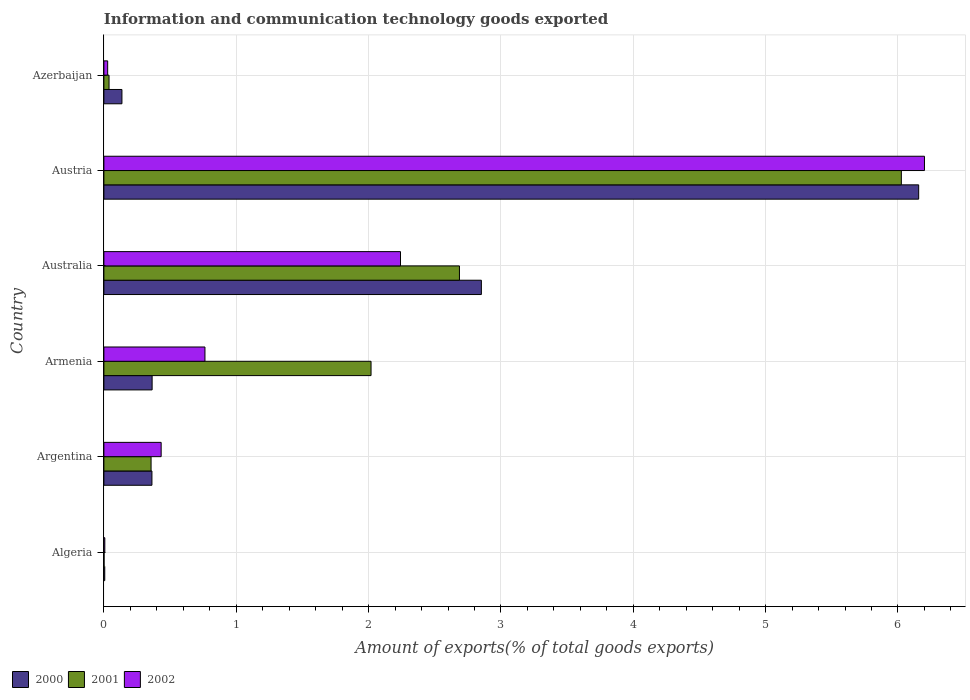Are the number of bars per tick equal to the number of legend labels?
Make the answer very short. Yes. Are the number of bars on each tick of the Y-axis equal?
Give a very brief answer. Yes. What is the label of the 3rd group of bars from the top?
Offer a terse response. Australia. What is the amount of goods exported in 2001 in Algeria?
Offer a terse response. 0. Across all countries, what is the maximum amount of goods exported in 2002?
Provide a short and direct response. 6.2. Across all countries, what is the minimum amount of goods exported in 2002?
Offer a terse response. 0.01. In which country was the amount of goods exported in 2002 maximum?
Your answer should be compact. Austria. In which country was the amount of goods exported in 2002 minimum?
Keep it short and to the point. Algeria. What is the total amount of goods exported in 2001 in the graph?
Give a very brief answer. 11.13. What is the difference between the amount of goods exported in 2001 in Algeria and that in Azerbaijan?
Ensure brevity in your answer.  -0.04. What is the difference between the amount of goods exported in 2000 in Argentina and the amount of goods exported in 2002 in Algeria?
Give a very brief answer. 0.36. What is the average amount of goods exported in 2000 per country?
Keep it short and to the point. 1.65. What is the difference between the amount of goods exported in 2000 and amount of goods exported in 2002 in Azerbaijan?
Ensure brevity in your answer.  0.11. In how many countries, is the amount of goods exported in 2000 greater than 2.4 %?
Keep it short and to the point. 2. What is the ratio of the amount of goods exported in 2002 in Austria to that in Azerbaijan?
Ensure brevity in your answer.  217.4. What is the difference between the highest and the second highest amount of goods exported in 2002?
Offer a very short reply. 3.96. What is the difference between the highest and the lowest amount of goods exported in 2000?
Keep it short and to the point. 6.15. Is the sum of the amount of goods exported in 2000 in Argentina and Australia greater than the maximum amount of goods exported in 2001 across all countries?
Give a very brief answer. No. Is it the case that in every country, the sum of the amount of goods exported in 2000 and amount of goods exported in 2001 is greater than the amount of goods exported in 2002?
Your response must be concise. Yes. How many bars are there?
Offer a very short reply. 18. Are all the bars in the graph horizontal?
Ensure brevity in your answer.  Yes. Are the values on the major ticks of X-axis written in scientific E-notation?
Provide a succinct answer. No. Where does the legend appear in the graph?
Offer a very short reply. Bottom left. What is the title of the graph?
Your answer should be compact. Information and communication technology goods exported. What is the label or title of the X-axis?
Offer a very short reply. Amount of exports(% of total goods exports). What is the Amount of exports(% of total goods exports) of 2000 in Algeria?
Your answer should be compact. 0.01. What is the Amount of exports(% of total goods exports) of 2001 in Algeria?
Give a very brief answer. 0. What is the Amount of exports(% of total goods exports) in 2002 in Algeria?
Offer a terse response. 0.01. What is the Amount of exports(% of total goods exports) in 2000 in Argentina?
Provide a short and direct response. 0.36. What is the Amount of exports(% of total goods exports) of 2001 in Argentina?
Offer a terse response. 0.36. What is the Amount of exports(% of total goods exports) in 2002 in Argentina?
Offer a terse response. 0.43. What is the Amount of exports(% of total goods exports) in 2000 in Armenia?
Provide a short and direct response. 0.36. What is the Amount of exports(% of total goods exports) in 2001 in Armenia?
Your answer should be very brief. 2.02. What is the Amount of exports(% of total goods exports) in 2002 in Armenia?
Provide a succinct answer. 0.76. What is the Amount of exports(% of total goods exports) in 2000 in Australia?
Give a very brief answer. 2.85. What is the Amount of exports(% of total goods exports) of 2001 in Australia?
Offer a very short reply. 2.69. What is the Amount of exports(% of total goods exports) of 2002 in Australia?
Give a very brief answer. 2.24. What is the Amount of exports(% of total goods exports) in 2000 in Austria?
Your response must be concise. 6.16. What is the Amount of exports(% of total goods exports) in 2001 in Austria?
Ensure brevity in your answer.  6.03. What is the Amount of exports(% of total goods exports) of 2002 in Austria?
Provide a succinct answer. 6.2. What is the Amount of exports(% of total goods exports) in 2000 in Azerbaijan?
Make the answer very short. 0.14. What is the Amount of exports(% of total goods exports) in 2001 in Azerbaijan?
Give a very brief answer. 0.04. What is the Amount of exports(% of total goods exports) in 2002 in Azerbaijan?
Your answer should be very brief. 0.03. Across all countries, what is the maximum Amount of exports(% of total goods exports) of 2000?
Make the answer very short. 6.16. Across all countries, what is the maximum Amount of exports(% of total goods exports) of 2001?
Your response must be concise. 6.03. Across all countries, what is the maximum Amount of exports(% of total goods exports) of 2002?
Provide a succinct answer. 6.2. Across all countries, what is the minimum Amount of exports(% of total goods exports) in 2000?
Provide a short and direct response. 0.01. Across all countries, what is the minimum Amount of exports(% of total goods exports) in 2001?
Provide a succinct answer. 0. Across all countries, what is the minimum Amount of exports(% of total goods exports) in 2002?
Offer a terse response. 0.01. What is the total Amount of exports(% of total goods exports) in 2000 in the graph?
Your answer should be compact. 9.88. What is the total Amount of exports(% of total goods exports) of 2001 in the graph?
Your answer should be compact. 11.13. What is the total Amount of exports(% of total goods exports) of 2002 in the graph?
Provide a succinct answer. 9.67. What is the difference between the Amount of exports(% of total goods exports) in 2000 in Algeria and that in Argentina?
Your response must be concise. -0.36. What is the difference between the Amount of exports(% of total goods exports) in 2001 in Algeria and that in Argentina?
Your response must be concise. -0.36. What is the difference between the Amount of exports(% of total goods exports) of 2002 in Algeria and that in Argentina?
Provide a succinct answer. -0.43. What is the difference between the Amount of exports(% of total goods exports) of 2000 in Algeria and that in Armenia?
Offer a terse response. -0.36. What is the difference between the Amount of exports(% of total goods exports) of 2001 in Algeria and that in Armenia?
Provide a succinct answer. -2.02. What is the difference between the Amount of exports(% of total goods exports) in 2002 in Algeria and that in Armenia?
Give a very brief answer. -0.76. What is the difference between the Amount of exports(% of total goods exports) of 2000 in Algeria and that in Australia?
Your answer should be compact. -2.85. What is the difference between the Amount of exports(% of total goods exports) in 2001 in Algeria and that in Australia?
Your answer should be compact. -2.69. What is the difference between the Amount of exports(% of total goods exports) of 2002 in Algeria and that in Australia?
Provide a short and direct response. -2.23. What is the difference between the Amount of exports(% of total goods exports) in 2000 in Algeria and that in Austria?
Provide a succinct answer. -6.15. What is the difference between the Amount of exports(% of total goods exports) of 2001 in Algeria and that in Austria?
Keep it short and to the point. -6.02. What is the difference between the Amount of exports(% of total goods exports) of 2002 in Algeria and that in Austria?
Give a very brief answer. -6.19. What is the difference between the Amount of exports(% of total goods exports) of 2000 in Algeria and that in Azerbaijan?
Give a very brief answer. -0.13. What is the difference between the Amount of exports(% of total goods exports) of 2001 in Algeria and that in Azerbaijan?
Offer a very short reply. -0.04. What is the difference between the Amount of exports(% of total goods exports) in 2002 in Algeria and that in Azerbaijan?
Your answer should be compact. -0.02. What is the difference between the Amount of exports(% of total goods exports) in 2000 in Argentina and that in Armenia?
Your response must be concise. -0. What is the difference between the Amount of exports(% of total goods exports) of 2001 in Argentina and that in Armenia?
Your answer should be very brief. -1.66. What is the difference between the Amount of exports(% of total goods exports) of 2002 in Argentina and that in Armenia?
Offer a very short reply. -0.33. What is the difference between the Amount of exports(% of total goods exports) in 2000 in Argentina and that in Australia?
Offer a very short reply. -2.49. What is the difference between the Amount of exports(% of total goods exports) of 2001 in Argentina and that in Australia?
Your answer should be compact. -2.33. What is the difference between the Amount of exports(% of total goods exports) in 2002 in Argentina and that in Australia?
Your answer should be compact. -1.81. What is the difference between the Amount of exports(% of total goods exports) in 2000 in Argentina and that in Austria?
Keep it short and to the point. -5.79. What is the difference between the Amount of exports(% of total goods exports) of 2001 in Argentina and that in Austria?
Provide a short and direct response. -5.67. What is the difference between the Amount of exports(% of total goods exports) of 2002 in Argentina and that in Austria?
Your answer should be compact. -5.77. What is the difference between the Amount of exports(% of total goods exports) of 2000 in Argentina and that in Azerbaijan?
Make the answer very short. 0.23. What is the difference between the Amount of exports(% of total goods exports) in 2001 in Argentina and that in Azerbaijan?
Make the answer very short. 0.32. What is the difference between the Amount of exports(% of total goods exports) of 2002 in Argentina and that in Azerbaijan?
Make the answer very short. 0.4. What is the difference between the Amount of exports(% of total goods exports) of 2000 in Armenia and that in Australia?
Your answer should be very brief. -2.49. What is the difference between the Amount of exports(% of total goods exports) in 2001 in Armenia and that in Australia?
Ensure brevity in your answer.  -0.67. What is the difference between the Amount of exports(% of total goods exports) of 2002 in Armenia and that in Australia?
Your response must be concise. -1.48. What is the difference between the Amount of exports(% of total goods exports) of 2000 in Armenia and that in Austria?
Provide a short and direct response. -5.79. What is the difference between the Amount of exports(% of total goods exports) of 2001 in Armenia and that in Austria?
Ensure brevity in your answer.  -4.01. What is the difference between the Amount of exports(% of total goods exports) of 2002 in Armenia and that in Austria?
Ensure brevity in your answer.  -5.44. What is the difference between the Amount of exports(% of total goods exports) in 2000 in Armenia and that in Azerbaijan?
Ensure brevity in your answer.  0.23. What is the difference between the Amount of exports(% of total goods exports) of 2001 in Armenia and that in Azerbaijan?
Make the answer very short. 1.98. What is the difference between the Amount of exports(% of total goods exports) in 2002 in Armenia and that in Azerbaijan?
Keep it short and to the point. 0.74. What is the difference between the Amount of exports(% of total goods exports) in 2000 in Australia and that in Austria?
Keep it short and to the point. -3.3. What is the difference between the Amount of exports(% of total goods exports) of 2001 in Australia and that in Austria?
Your response must be concise. -3.34. What is the difference between the Amount of exports(% of total goods exports) of 2002 in Australia and that in Austria?
Provide a succinct answer. -3.96. What is the difference between the Amount of exports(% of total goods exports) of 2000 in Australia and that in Azerbaijan?
Provide a short and direct response. 2.72. What is the difference between the Amount of exports(% of total goods exports) of 2001 in Australia and that in Azerbaijan?
Provide a succinct answer. 2.65. What is the difference between the Amount of exports(% of total goods exports) in 2002 in Australia and that in Azerbaijan?
Offer a terse response. 2.21. What is the difference between the Amount of exports(% of total goods exports) of 2000 in Austria and that in Azerbaijan?
Offer a very short reply. 6.02. What is the difference between the Amount of exports(% of total goods exports) of 2001 in Austria and that in Azerbaijan?
Your answer should be very brief. 5.99. What is the difference between the Amount of exports(% of total goods exports) in 2002 in Austria and that in Azerbaijan?
Your answer should be very brief. 6.17. What is the difference between the Amount of exports(% of total goods exports) of 2000 in Algeria and the Amount of exports(% of total goods exports) of 2001 in Argentina?
Give a very brief answer. -0.35. What is the difference between the Amount of exports(% of total goods exports) of 2000 in Algeria and the Amount of exports(% of total goods exports) of 2002 in Argentina?
Make the answer very short. -0.43. What is the difference between the Amount of exports(% of total goods exports) in 2001 in Algeria and the Amount of exports(% of total goods exports) in 2002 in Argentina?
Keep it short and to the point. -0.43. What is the difference between the Amount of exports(% of total goods exports) of 2000 in Algeria and the Amount of exports(% of total goods exports) of 2001 in Armenia?
Your response must be concise. -2.01. What is the difference between the Amount of exports(% of total goods exports) of 2000 in Algeria and the Amount of exports(% of total goods exports) of 2002 in Armenia?
Ensure brevity in your answer.  -0.76. What is the difference between the Amount of exports(% of total goods exports) of 2001 in Algeria and the Amount of exports(% of total goods exports) of 2002 in Armenia?
Your answer should be compact. -0.76. What is the difference between the Amount of exports(% of total goods exports) of 2000 in Algeria and the Amount of exports(% of total goods exports) of 2001 in Australia?
Your answer should be compact. -2.68. What is the difference between the Amount of exports(% of total goods exports) of 2000 in Algeria and the Amount of exports(% of total goods exports) of 2002 in Australia?
Your answer should be very brief. -2.23. What is the difference between the Amount of exports(% of total goods exports) of 2001 in Algeria and the Amount of exports(% of total goods exports) of 2002 in Australia?
Keep it short and to the point. -2.24. What is the difference between the Amount of exports(% of total goods exports) in 2000 in Algeria and the Amount of exports(% of total goods exports) in 2001 in Austria?
Keep it short and to the point. -6.02. What is the difference between the Amount of exports(% of total goods exports) of 2000 in Algeria and the Amount of exports(% of total goods exports) of 2002 in Austria?
Ensure brevity in your answer.  -6.19. What is the difference between the Amount of exports(% of total goods exports) of 2001 in Algeria and the Amount of exports(% of total goods exports) of 2002 in Austria?
Your answer should be compact. -6.2. What is the difference between the Amount of exports(% of total goods exports) of 2000 in Algeria and the Amount of exports(% of total goods exports) of 2001 in Azerbaijan?
Provide a short and direct response. -0.03. What is the difference between the Amount of exports(% of total goods exports) of 2000 in Algeria and the Amount of exports(% of total goods exports) of 2002 in Azerbaijan?
Provide a succinct answer. -0.02. What is the difference between the Amount of exports(% of total goods exports) of 2001 in Algeria and the Amount of exports(% of total goods exports) of 2002 in Azerbaijan?
Your response must be concise. -0.03. What is the difference between the Amount of exports(% of total goods exports) of 2000 in Argentina and the Amount of exports(% of total goods exports) of 2001 in Armenia?
Provide a short and direct response. -1.66. What is the difference between the Amount of exports(% of total goods exports) in 2000 in Argentina and the Amount of exports(% of total goods exports) in 2002 in Armenia?
Your answer should be compact. -0.4. What is the difference between the Amount of exports(% of total goods exports) of 2001 in Argentina and the Amount of exports(% of total goods exports) of 2002 in Armenia?
Your answer should be very brief. -0.41. What is the difference between the Amount of exports(% of total goods exports) of 2000 in Argentina and the Amount of exports(% of total goods exports) of 2001 in Australia?
Provide a short and direct response. -2.32. What is the difference between the Amount of exports(% of total goods exports) of 2000 in Argentina and the Amount of exports(% of total goods exports) of 2002 in Australia?
Offer a terse response. -1.88. What is the difference between the Amount of exports(% of total goods exports) of 2001 in Argentina and the Amount of exports(% of total goods exports) of 2002 in Australia?
Make the answer very short. -1.88. What is the difference between the Amount of exports(% of total goods exports) of 2000 in Argentina and the Amount of exports(% of total goods exports) of 2001 in Austria?
Provide a short and direct response. -5.66. What is the difference between the Amount of exports(% of total goods exports) in 2000 in Argentina and the Amount of exports(% of total goods exports) in 2002 in Austria?
Your answer should be very brief. -5.84. What is the difference between the Amount of exports(% of total goods exports) of 2001 in Argentina and the Amount of exports(% of total goods exports) of 2002 in Austria?
Your answer should be compact. -5.84. What is the difference between the Amount of exports(% of total goods exports) of 2000 in Argentina and the Amount of exports(% of total goods exports) of 2001 in Azerbaijan?
Your answer should be very brief. 0.32. What is the difference between the Amount of exports(% of total goods exports) in 2000 in Argentina and the Amount of exports(% of total goods exports) in 2002 in Azerbaijan?
Make the answer very short. 0.33. What is the difference between the Amount of exports(% of total goods exports) of 2001 in Argentina and the Amount of exports(% of total goods exports) of 2002 in Azerbaijan?
Your answer should be compact. 0.33. What is the difference between the Amount of exports(% of total goods exports) of 2000 in Armenia and the Amount of exports(% of total goods exports) of 2001 in Australia?
Your response must be concise. -2.32. What is the difference between the Amount of exports(% of total goods exports) of 2000 in Armenia and the Amount of exports(% of total goods exports) of 2002 in Australia?
Give a very brief answer. -1.88. What is the difference between the Amount of exports(% of total goods exports) in 2001 in Armenia and the Amount of exports(% of total goods exports) in 2002 in Australia?
Your answer should be very brief. -0.22. What is the difference between the Amount of exports(% of total goods exports) of 2000 in Armenia and the Amount of exports(% of total goods exports) of 2001 in Austria?
Your answer should be very brief. -5.66. What is the difference between the Amount of exports(% of total goods exports) of 2000 in Armenia and the Amount of exports(% of total goods exports) of 2002 in Austria?
Your response must be concise. -5.84. What is the difference between the Amount of exports(% of total goods exports) in 2001 in Armenia and the Amount of exports(% of total goods exports) in 2002 in Austria?
Keep it short and to the point. -4.18. What is the difference between the Amount of exports(% of total goods exports) of 2000 in Armenia and the Amount of exports(% of total goods exports) of 2001 in Azerbaijan?
Make the answer very short. 0.33. What is the difference between the Amount of exports(% of total goods exports) in 2000 in Armenia and the Amount of exports(% of total goods exports) in 2002 in Azerbaijan?
Your answer should be very brief. 0.34. What is the difference between the Amount of exports(% of total goods exports) in 2001 in Armenia and the Amount of exports(% of total goods exports) in 2002 in Azerbaijan?
Your answer should be compact. 1.99. What is the difference between the Amount of exports(% of total goods exports) in 2000 in Australia and the Amount of exports(% of total goods exports) in 2001 in Austria?
Keep it short and to the point. -3.17. What is the difference between the Amount of exports(% of total goods exports) in 2000 in Australia and the Amount of exports(% of total goods exports) in 2002 in Austria?
Your answer should be very brief. -3.35. What is the difference between the Amount of exports(% of total goods exports) of 2001 in Australia and the Amount of exports(% of total goods exports) of 2002 in Austria?
Keep it short and to the point. -3.51. What is the difference between the Amount of exports(% of total goods exports) in 2000 in Australia and the Amount of exports(% of total goods exports) in 2001 in Azerbaijan?
Provide a short and direct response. 2.81. What is the difference between the Amount of exports(% of total goods exports) in 2000 in Australia and the Amount of exports(% of total goods exports) in 2002 in Azerbaijan?
Give a very brief answer. 2.82. What is the difference between the Amount of exports(% of total goods exports) in 2001 in Australia and the Amount of exports(% of total goods exports) in 2002 in Azerbaijan?
Keep it short and to the point. 2.66. What is the difference between the Amount of exports(% of total goods exports) of 2000 in Austria and the Amount of exports(% of total goods exports) of 2001 in Azerbaijan?
Your response must be concise. 6.12. What is the difference between the Amount of exports(% of total goods exports) of 2000 in Austria and the Amount of exports(% of total goods exports) of 2002 in Azerbaijan?
Ensure brevity in your answer.  6.13. What is the difference between the Amount of exports(% of total goods exports) of 2001 in Austria and the Amount of exports(% of total goods exports) of 2002 in Azerbaijan?
Make the answer very short. 6. What is the average Amount of exports(% of total goods exports) of 2000 per country?
Keep it short and to the point. 1.65. What is the average Amount of exports(% of total goods exports) in 2001 per country?
Offer a terse response. 1.85. What is the average Amount of exports(% of total goods exports) in 2002 per country?
Keep it short and to the point. 1.61. What is the difference between the Amount of exports(% of total goods exports) in 2000 and Amount of exports(% of total goods exports) in 2001 in Algeria?
Your response must be concise. 0.01. What is the difference between the Amount of exports(% of total goods exports) of 2000 and Amount of exports(% of total goods exports) of 2002 in Algeria?
Give a very brief answer. -0. What is the difference between the Amount of exports(% of total goods exports) of 2001 and Amount of exports(% of total goods exports) of 2002 in Algeria?
Offer a very short reply. -0.01. What is the difference between the Amount of exports(% of total goods exports) in 2000 and Amount of exports(% of total goods exports) in 2001 in Argentina?
Offer a very short reply. 0.01. What is the difference between the Amount of exports(% of total goods exports) in 2000 and Amount of exports(% of total goods exports) in 2002 in Argentina?
Your answer should be very brief. -0.07. What is the difference between the Amount of exports(% of total goods exports) in 2001 and Amount of exports(% of total goods exports) in 2002 in Argentina?
Provide a succinct answer. -0.08. What is the difference between the Amount of exports(% of total goods exports) of 2000 and Amount of exports(% of total goods exports) of 2001 in Armenia?
Your response must be concise. -1.65. What is the difference between the Amount of exports(% of total goods exports) of 2000 and Amount of exports(% of total goods exports) of 2002 in Armenia?
Your response must be concise. -0.4. What is the difference between the Amount of exports(% of total goods exports) of 2001 and Amount of exports(% of total goods exports) of 2002 in Armenia?
Keep it short and to the point. 1.25. What is the difference between the Amount of exports(% of total goods exports) in 2000 and Amount of exports(% of total goods exports) in 2001 in Australia?
Make the answer very short. 0.17. What is the difference between the Amount of exports(% of total goods exports) in 2000 and Amount of exports(% of total goods exports) in 2002 in Australia?
Your answer should be very brief. 0.61. What is the difference between the Amount of exports(% of total goods exports) of 2001 and Amount of exports(% of total goods exports) of 2002 in Australia?
Make the answer very short. 0.45. What is the difference between the Amount of exports(% of total goods exports) in 2000 and Amount of exports(% of total goods exports) in 2001 in Austria?
Provide a short and direct response. 0.13. What is the difference between the Amount of exports(% of total goods exports) in 2000 and Amount of exports(% of total goods exports) in 2002 in Austria?
Make the answer very short. -0.04. What is the difference between the Amount of exports(% of total goods exports) in 2001 and Amount of exports(% of total goods exports) in 2002 in Austria?
Offer a very short reply. -0.17. What is the difference between the Amount of exports(% of total goods exports) in 2000 and Amount of exports(% of total goods exports) in 2001 in Azerbaijan?
Give a very brief answer. 0.1. What is the difference between the Amount of exports(% of total goods exports) of 2000 and Amount of exports(% of total goods exports) of 2002 in Azerbaijan?
Give a very brief answer. 0.11. What is the difference between the Amount of exports(% of total goods exports) in 2001 and Amount of exports(% of total goods exports) in 2002 in Azerbaijan?
Make the answer very short. 0.01. What is the ratio of the Amount of exports(% of total goods exports) of 2000 in Algeria to that in Argentina?
Give a very brief answer. 0.02. What is the ratio of the Amount of exports(% of total goods exports) of 2001 in Algeria to that in Argentina?
Ensure brevity in your answer.  0. What is the ratio of the Amount of exports(% of total goods exports) of 2002 in Algeria to that in Argentina?
Provide a short and direct response. 0.02. What is the ratio of the Amount of exports(% of total goods exports) of 2000 in Algeria to that in Armenia?
Ensure brevity in your answer.  0.02. What is the ratio of the Amount of exports(% of total goods exports) of 2001 in Algeria to that in Armenia?
Provide a succinct answer. 0. What is the ratio of the Amount of exports(% of total goods exports) in 2002 in Algeria to that in Armenia?
Provide a succinct answer. 0.01. What is the ratio of the Amount of exports(% of total goods exports) in 2000 in Algeria to that in Australia?
Your response must be concise. 0. What is the ratio of the Amount of exports(% of total goods exports) in 2001 in Algeria to that in Australia?
Offer a very short reply. 0. What is the ratio of the Amount of exports(% of total goods exports) of 2002 in Algeria to that in Australia?
Ensure brevity in your answer.  0. What is the ratio of the Amount of exports(% of total goods exports) of 2000 in Algeria to that in Austria?
Offer a terse response. 0. What is the ratio of the Amount of exports(% of total goods exports) of 2001 in Algeria to that in Austria?
Provide a succinct answer. 0. What is the ratio of the Amount of exports(% of total goods exports) of 2002 in Algeria to that in Austria?
Offer a terse response. 0. What is the ratio of the Amount of exports(% of total goods exports) of 2000 in Algeria to that in Azerbaijan?
Ensure brevity in your answer.  0.05. What is the ratio of the Amount of exports(% of total goods exports) in 2001 in Algeria to that in Azerbaijan?
Your response must be concise. 0.03. What is the ratio of the Amount of exports(% of total goods exports) of 2002 in Algeria to that in Azerbaijan?
Your answer should be compact. 0.24. What is the ratio of the Amount of exports(% of total goods exports) in 2000 in Argentina to that in Armenia?
Offer a very short reply. 1. What is the ratio of the Amount of exports(% of total goods exports) in 2001 in Argentina to that in Armenia?
Your response must be concise. 0.18. What is the ratio of the Amount of exports(% of total goods exports) of 2002 in Argentina to that in Armenia?
Your response must be concise. 0.57. What is the ratio of the Amount of exports(% of total goods exports) in 2000 in Argentina to that in Australia?
Your answer should be very brief. 0.13. What is the ratio of the Amount of exports(% of total goods exports) of 2001 in Argentina to that in Australia?
Offer a terse response. 0.13. What is the ratio of the Amount of exports(% of total goods exports) of 2002 in Argentina to that in Australia?
Offer a terse response. 0.19. What is the ratio of the Amount of exports(% of total goods exports) in 2000 in Argentina to that in Austria?
Your response must be concise. 0.06. What is the ratio of the Amount of exports(% of total goods exports) in 2001 in Argentina to that in Austria?
Your response must be concise. 0.06. What is the ratio of the Amount of exports(% of total goods exports) of 2002 in Argentina to that in Austria?
Your answer should be very brief. 0.07. What is the ratio of the Amount of exports(% of total goods exports) in 2000 in Argentina to that in Azerbaijan?
Provide a short and direct response. 2.66. What is the ratio of the Amount of exports(% of total goods exports) in 2001 in Argentina to that in Azerbaijan?
Provide a succinct answer. 9.15. What is the ratio of the Amount of exports(% of total goods exports) in 2002 in Argentina to that in Azerbaijan?
Give a very brief answer. 15.17. What is the ratio of the Amount of exports(% of total goods exports) of 2000 in Armenia to that in Australia?
Your answer should be compact. 0.13. What is the ratio of the Amount of exports(% of total goods exports) in 2001 in Armenia to that in Australia?
Your response must be concise. 0.75. What is the ratio of the Amount of exports(% of total goods exports) in 2002 in Armenia to that in Australia?
Your response must be concise. 0.34. What is the ratio of the Amount of exports(% of total goods exports) of 2000 in Armenia to that in Austria?
Your response must be concise. 0.06. What is the ratio of the Amount of exports(% of total goods exports) in 2001 in Armenia to that in Austria?
Ensure brevity in your answer.  0.34. What is the ratio of the Amount of exports(% of total goods exports) in 2002 in Armenia to that in Austria?
Your response must be concise. 0.12. What is the ratio of the Amount of exports(% of total goods exports) in 2000 in Armenia to that in Azerbaijan?
Provide a succinct answer. 2.67. What is the ratio of the Amount of exports(% of total goods exports) in 2001 in Armenia to that in Azerbaijan?
Provide a short and direct response. 51.8. What is the ratio of the Amount of exports(% of total goods exports) of 2002 in Armenia to that in Azerbaijan?
Ensure brevity in your answer.  26.77. What is the ratio of the Amount of exports(% of total goods exports) of 2000 in Australia to that in Austria?
Your answer should be very brief. 0.46. What is the ratio of the Amount of exports(% of total goods exports) in 2001 in Australia to that in Austria?
Make the answer very short. 0.45. What is the ratio of the Amount of exports(% of total goods exports) of 2002 in Australia to that in Austria?
Make the answer very short. 0.36. What is the ratio of the Amount of exports(% of total goods exports) in 2000 in Australia to that in Azerbaijan?
Provide a succinct answer. 20.91. What is the ratio of the Amount of exports(% of total goods exports) in 2001 in Australia to that in Azerbaijan?
Make the answer very short. 68.95. What is the ratio of the Amount of exports(% of total goods exports) in 2002 in Australia to that in Azerbaijan?
Keep it short and to the point. 78.58. What is the ratio of the Amount of exports(% of total goods exports) in 2000 in Austria to that in Azerbaijan?
Your response must be concise. 45.14. What is the ratio of the Amount of exports(% of total goods exports) in 2001 in Austria to that in Azerbaijan?
Ensure brevity in your answer.  154.63. What is the ratio of the Amount of exports(% of total goods exports) in 2002 in Austria to that in Azerbaijan?
Offer a very short reply. 217.4. What is the difference between the highest and the second highest Amount of exports(% of total goods exports) of 2000?
Keep it short and to the point. 3.3. What is the difference between the highest and the second highest Amount of exports(% of total goods exports) of 2001?
Your response must be concise. 3.34. What is the difference between the highest and the second highest Amount of exports(% of total goods exports) of 2002?
Your response must be concise. 3.96. What is the difference between the highest and the lowest Amount of exports(% of total goods exports) of 2000?
Ensure brevity in your answer.  6.15. What is the difference between the highest and the lowest Amount of exports(% of total goods exports) in 2001?
Give a very brief answer. 6.02. What is the difference between the highest and the lowest Amount of exports(% of total goods exports) of 2002?
Ensure brevity in your answer.  6.19. 